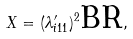<formula> <loc_0><loc_0><loc_500><loc_500>X = ( \lambda _ { i 1 1 } ^ { \prime } ) ^ { 2 } \text {BR} ,</formula> 